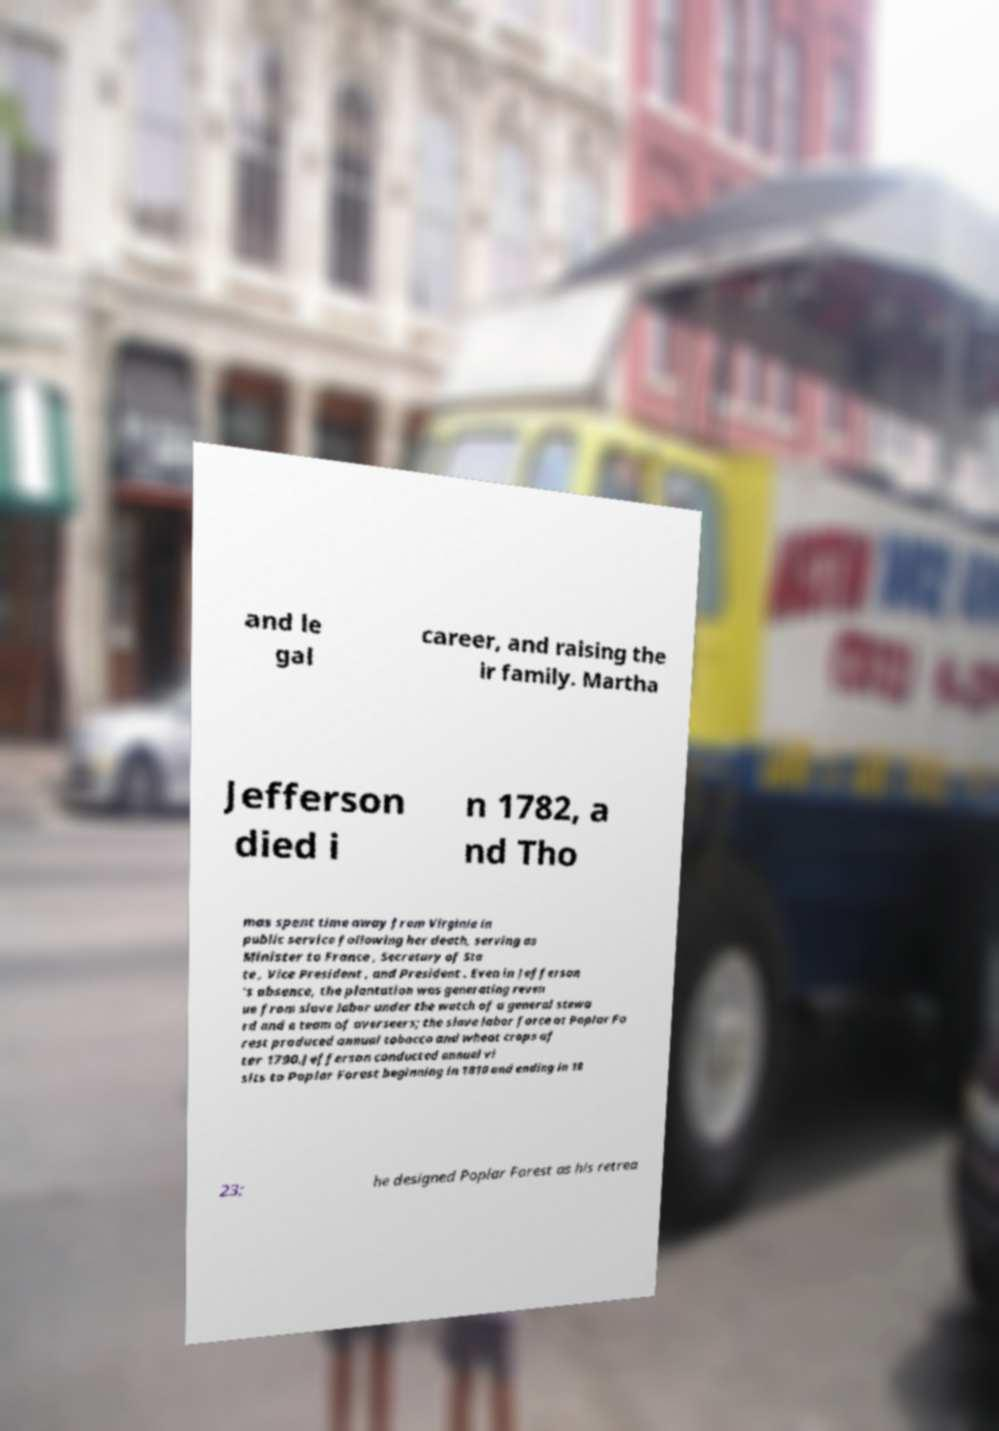Please identify and transcribe the text found in this image. and le gal career, and raising the ir family. Martha Jefferson died i n 1782, a nd Tho mas spent time away from Virginia in public service following her death, serving as Minister to France , Secretary of Sta te , Vice President , and President . Even in Jefferson 's absence, the plantation was generating reven ue from slave labor under the watch of a general stewa rd and a team of overseers; the slave labor force at Poplar Fo rest produced annual tobacco and wheat crops af ter 1790.Jefferson conducted annual vi sits to Poplar Forest beginning in 1810 and ending in 18 23; he designed Poplar Forest as his retrea 